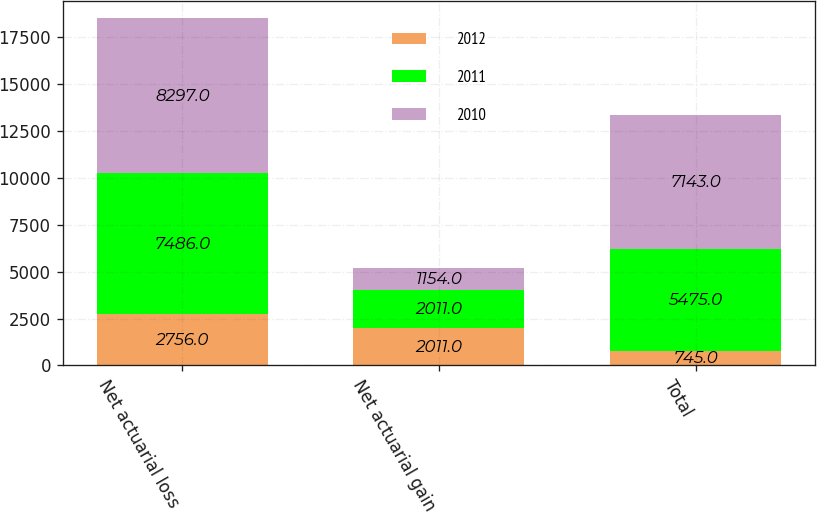Convert chart to OTSL. <chart><loc_0><loc_0><loc_500><loc_500><stacked_bar_chart><ecel><fcel>Net actuarial loss<fcel>Net actuarial gain<fcel>Total<nl><fcel>2012<fcel>2756<fcel>2011<fcel>745<nl><fcel>2011<fcel>7486<fcel>2011<fcel>5475<nl><fcel>2010<fcel>8297<fcel>1154<fcel>7143<nl></chart> 